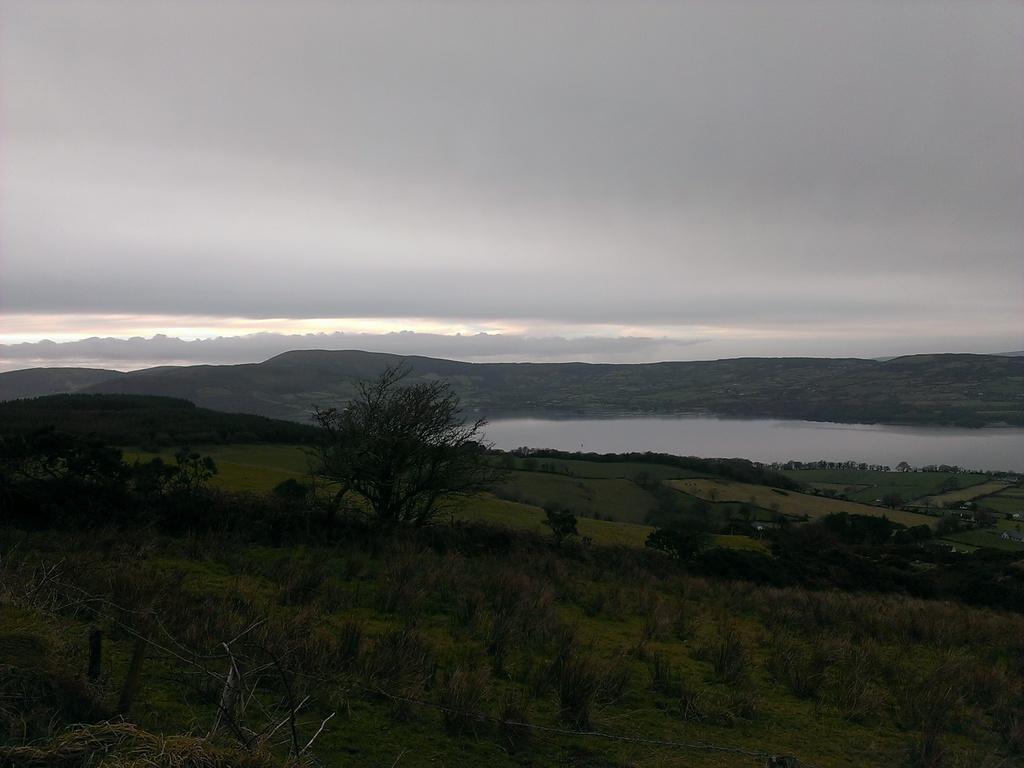In one or two sentences, can you explain what this image depicts? In this image I can see few trees, water and few mountains. The sky is in white and grey color. 